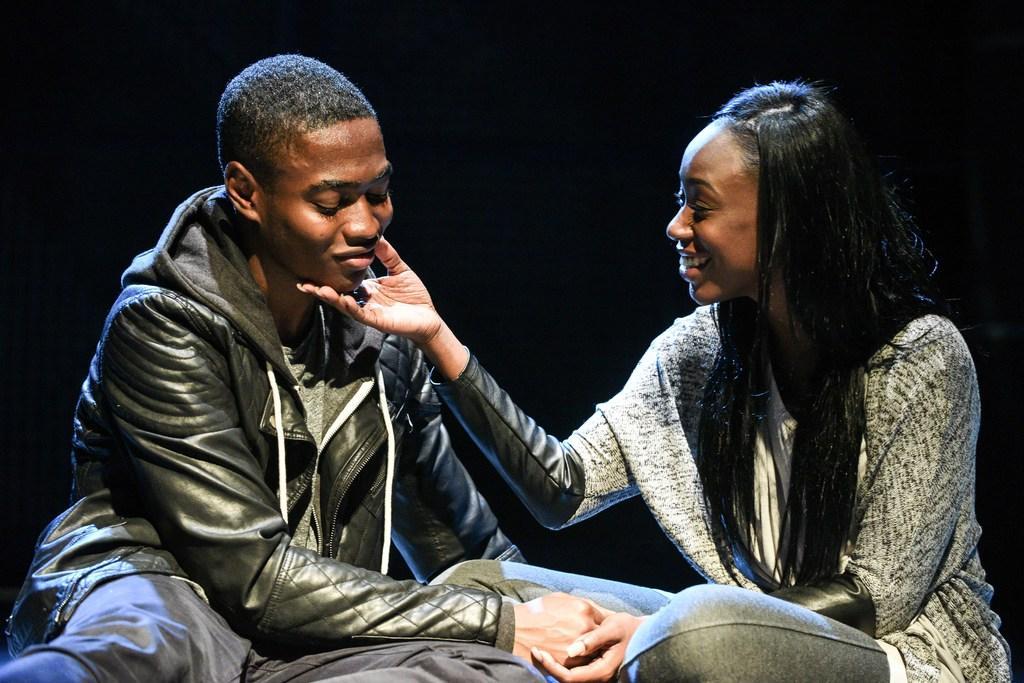Please provide a concise description of this image. The woman in the grey T-shirt is sitting and she is holding the hand of the man in her hand. She is smiling. Beside her, the man in the black jacket is sitting. He is smiling. In the background, it is black in color. 